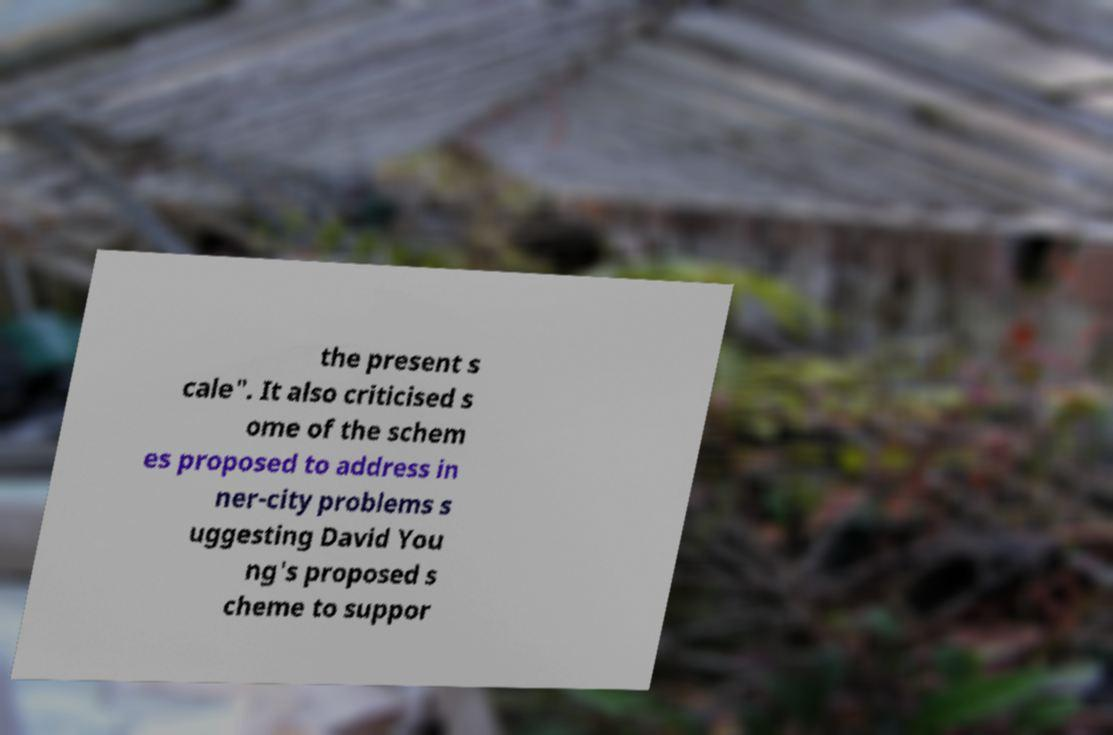Can you read and provide the text displayed in the image?This photo seems to have some interesting text. Can you extract and type it out for me? the present s cale". It also criticised s ome of the schem es proposed to address in ner-city problems s uggesting David You ng's proposed s cheme to suppor 